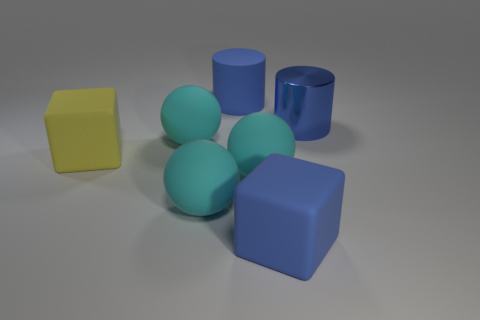How many cyan spheres must be subtracted to get 1 cyan spheres? 2 Add 2 blue metal cylinders. How many objects exist? 9 Subtract all blocks. How many objects are left? 5 Add 2 blue metallic things. How many blue metallic things are left? 3 Add 7 blue rubber cylinders. How many blue rubber cylinders exist? 8 Subtract 0 brown spheres. How many objects are left? 7 Subtract all big cyan things. Subtract all cyan balls. How many objects are left? 1 